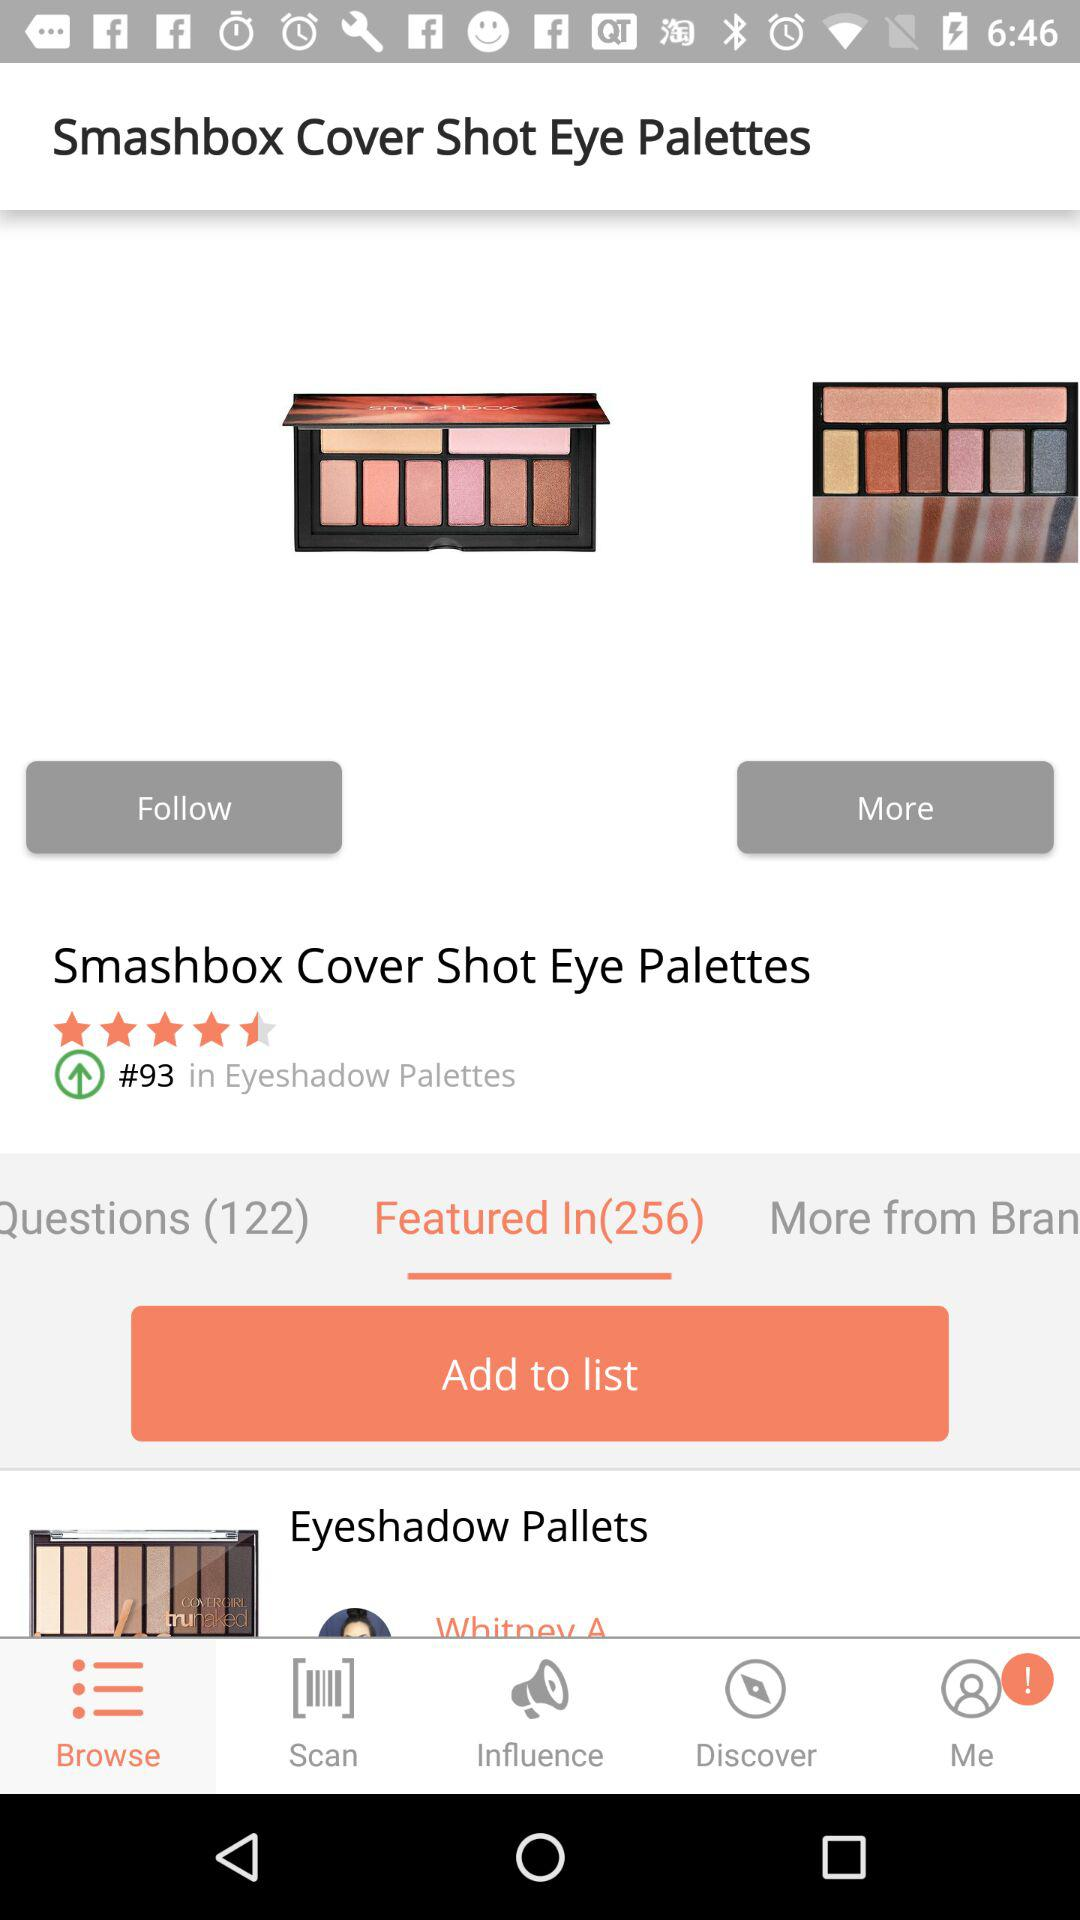How many products are in the eyeshadow palettes category?
Answer the question using a single word or phrase. 93 